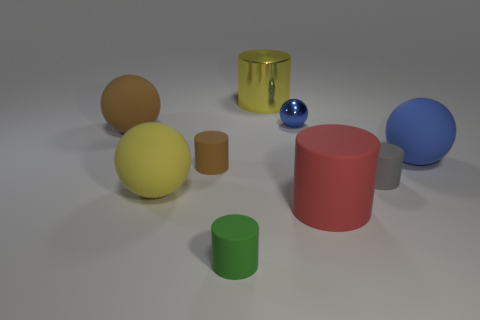Do the small matte object that is to the left of the green cylinder and the tiny metal thing have the same shape?
Ensure brevity in your answer.  No. Is the number of tiny objects that are in front of the small gray rubber cylinder greater than the number of big green cylinders?
Your response must be concise. Yes. How many balls are yellow objects or big purple objects?
Give a very brief answer. 1. What color is the large cylinder in front of the blue thing that is in front of the big brown matte object?
Give a very brief answer. Red. There is a large shiny cylinder; is its color the same as the large rubber sphere that is in front of the blue matte ball?
Provide a short and direct response. Yes. The brown cylinder that is the same material as the large red cylinder is what size?
Your answer should be very brief. Small. There is a blue object that is in front of the blue sphere that is on the left side of the large blue object; are there any green cylinders right of it?
Offer a terse response. No. How many matte cylinders have the same size as the yellow matte thing?
Offer a terse response. 1. There is a rubber sphere right of the green object; is it the same size as the blue thing behind the large blue ball?
Offer a very short reply. No. There is a big object that is both to the left of the tiny sphere and in front of the blue matte ball; what is its shape?
Your answer should be compact. Sphere. 